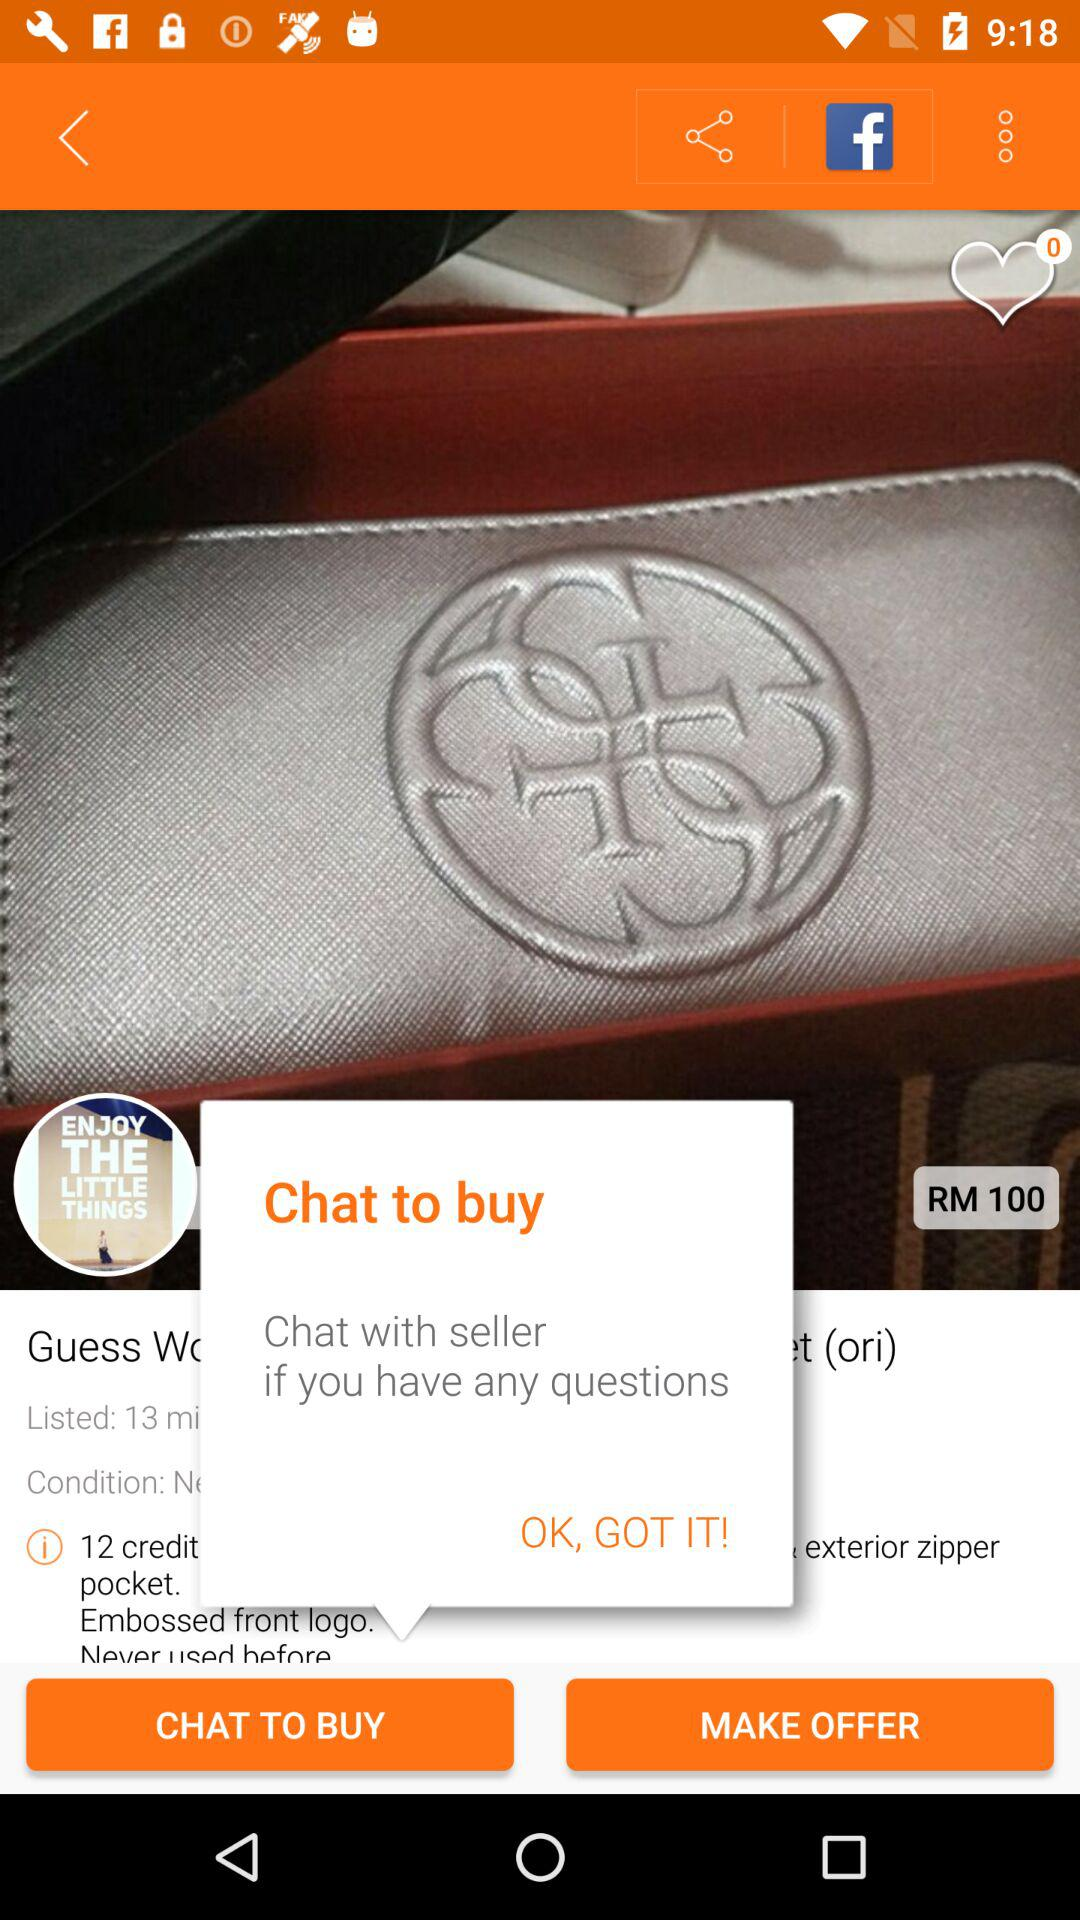How many credit pockets does the wallet have? The wallet in the image has a total of 12 credit card pockets, as indicated in the accompanying description, providing ample space for organizing cards and ensuring they are easily accessible. 